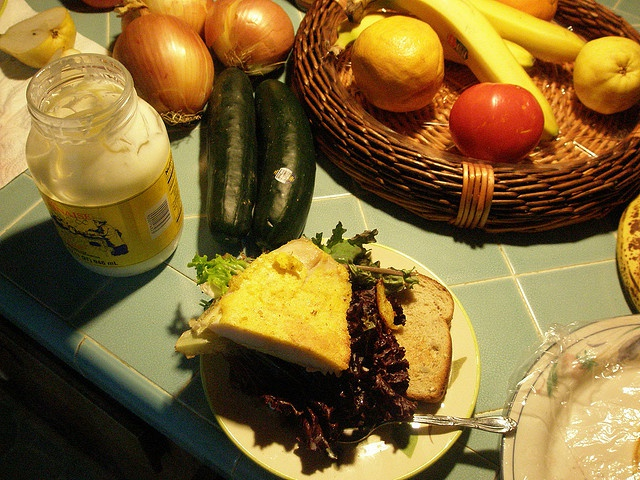Describe the objects in this image and their specific colors. I can see dining table in black, tan, maroon, khaki, and brown tones, sandwich in salmon, black, gold, and orange tones, bottle in salmon, tan, and olive tones, banana in salmon, yellow, gold, red, and orange tones, and orange in salmon, maroon, gold, and orange tones in this image. 